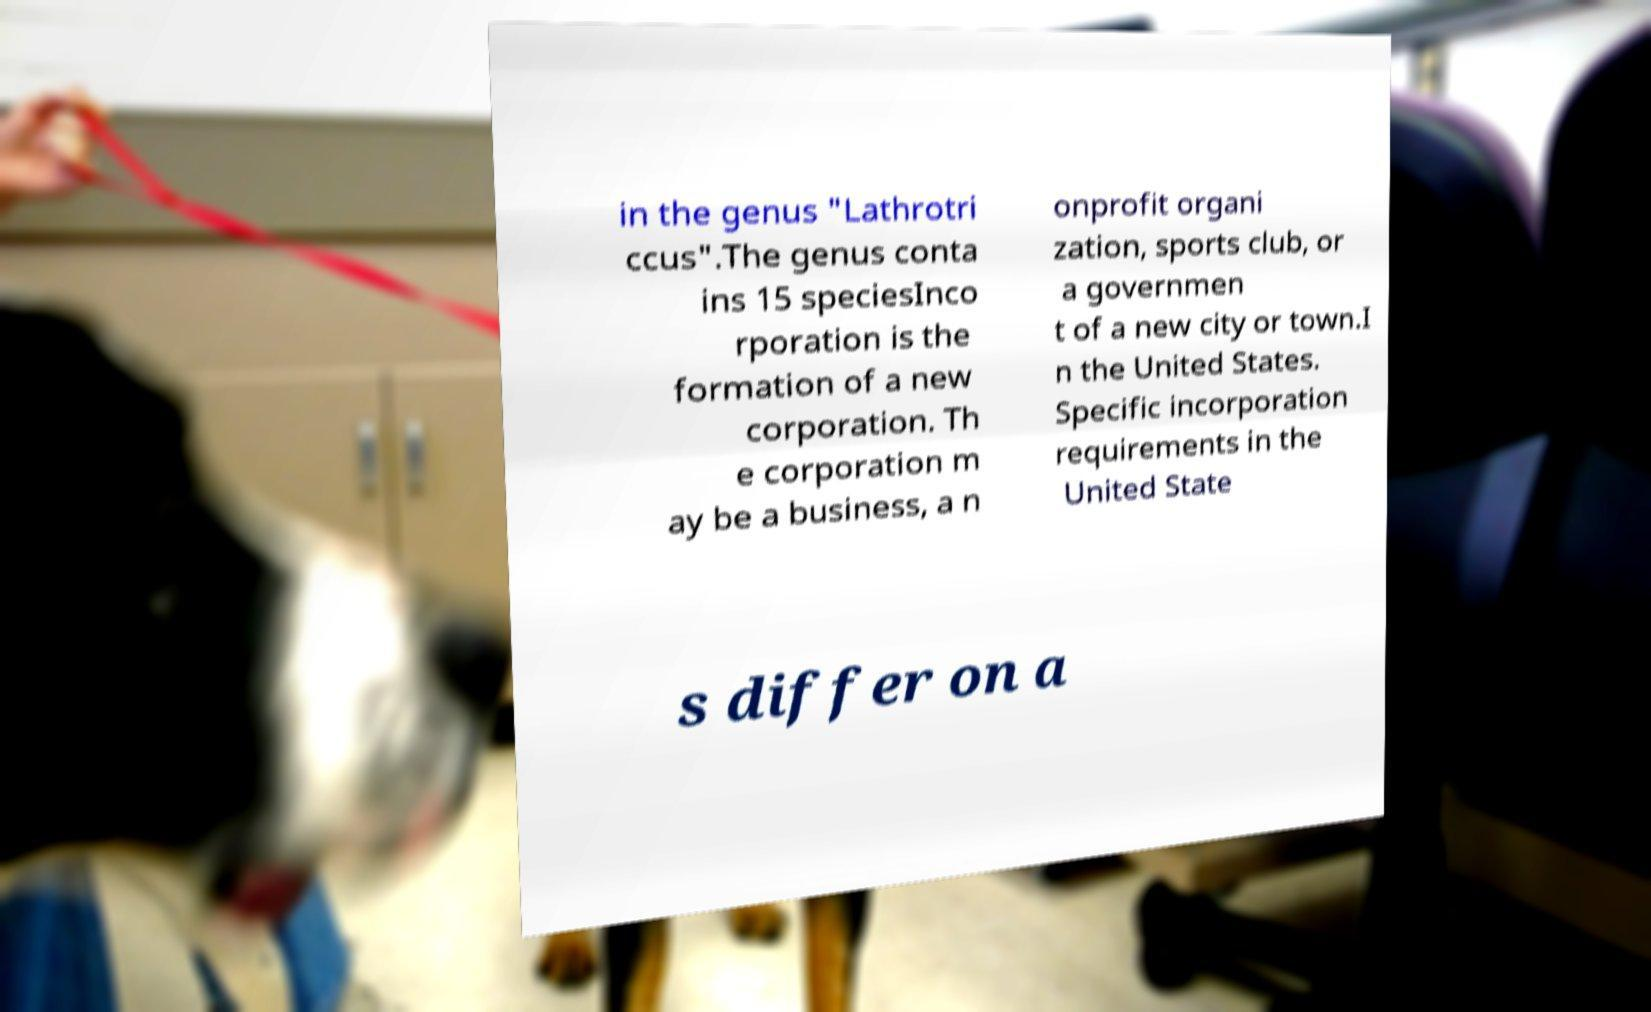There's text embedded in this image that I need extracted. Can you transcribe it verbatim? in the genus "Lathrotri ccus".The genus conta ins 15 speciesInco rporation is the formation of a new corporation. Th e corporation m ay be a business, a n onprofit organi zation, sports club, or a governmen t of a new city or town.I n the United States. Specific incorporation requirements in the United State s differ on a 